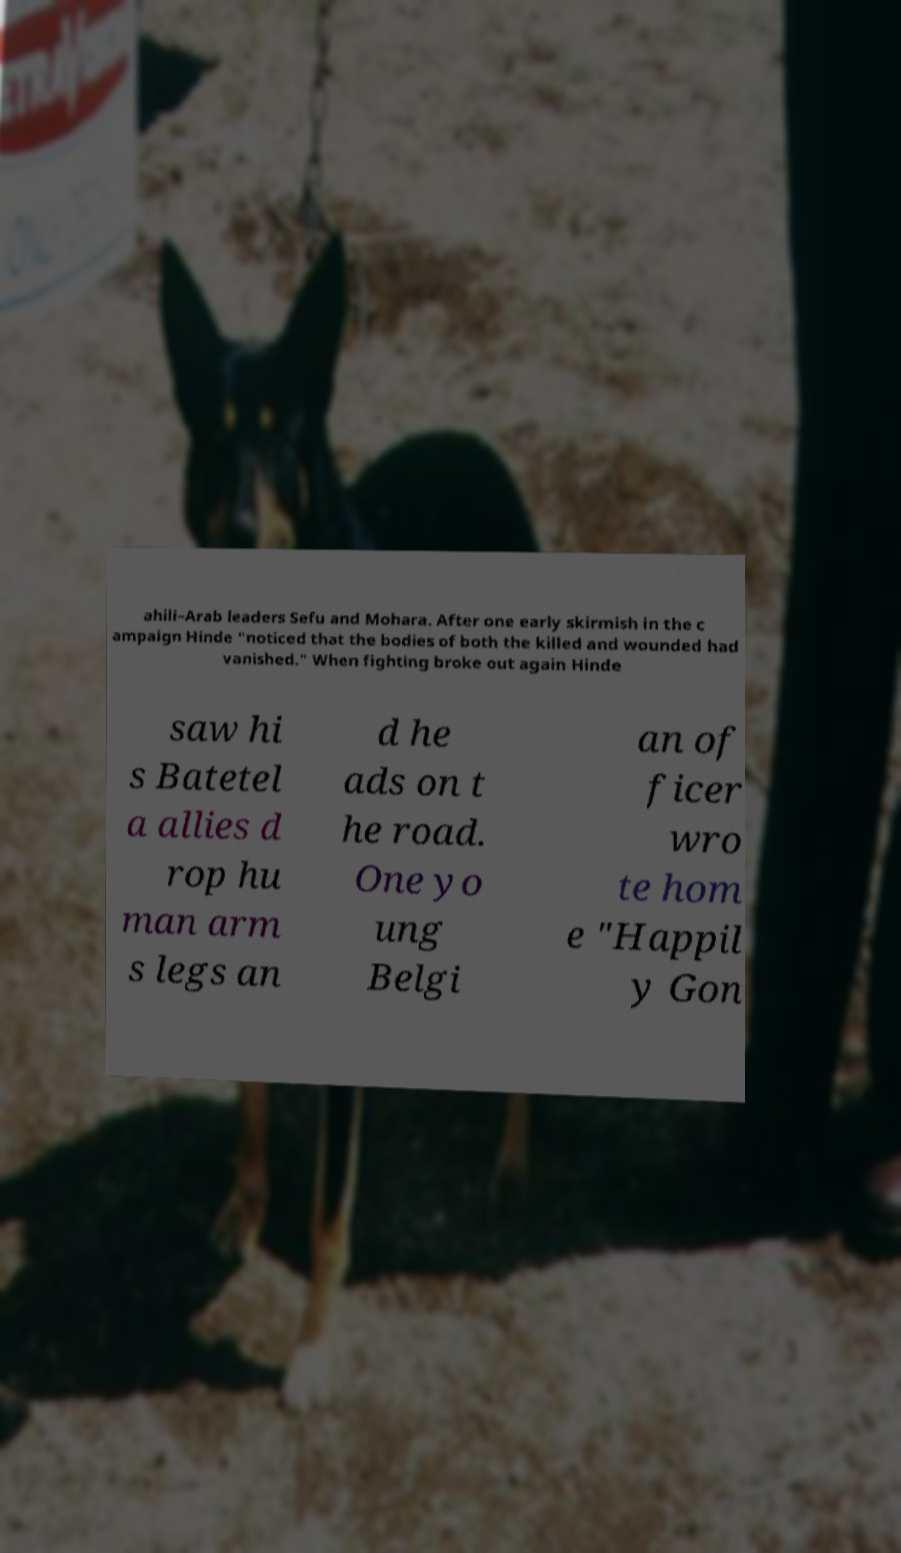Please identify and transcribe the text found in this image. ahili–Arab leaders Sefu and Mohara. After one early skirmish in the c ampaign Hinde "noticed that the bodies of both the killed and wounded had vanished." When fighting broke out again Hinde saw hi s Batetel a allies d rop hu man arm s legs an d he ads on t he road. One yo ung Belgi an of ficer wro te hom e "Happil y Gon 